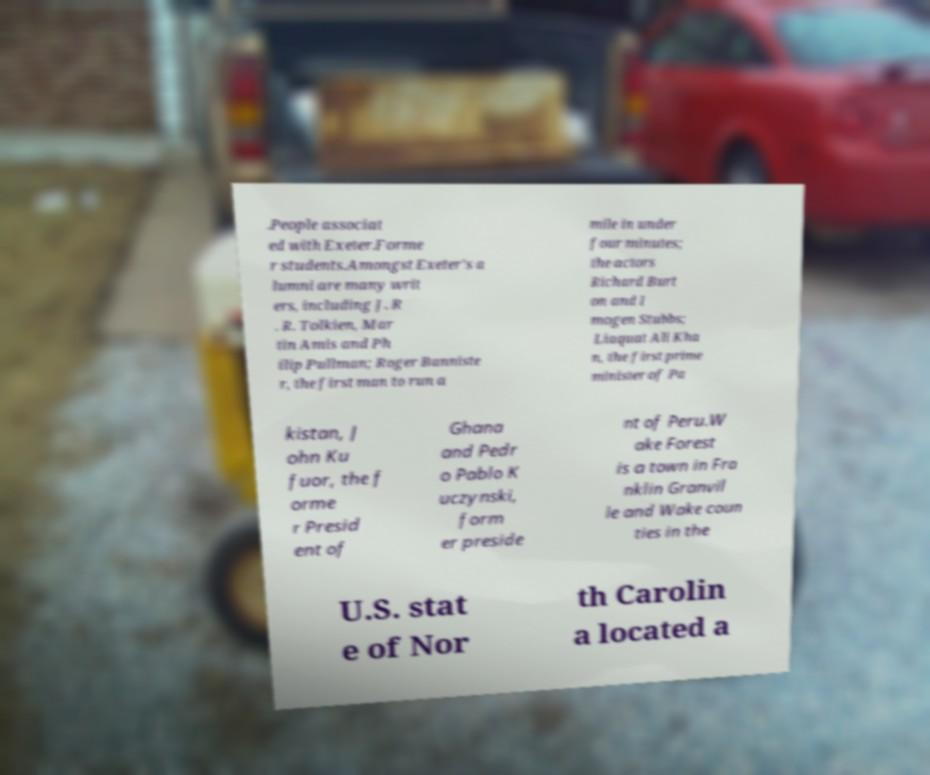Could you assist in decoding the text presented in this image and type it out clearly? .People associat ed with Exeter.Forme r students.Amongst Exeter's a lumni are many writ ers, including J. R . R. Tolkien, Mar tin Amis and Ph ilip Pullman; Roger Banniste r, the first man to run a mile in under four minutes; the actors Richard Burt on and I mogen Stubbs; Liaquat Ali Kha n, the first prime minister of Pa kistan, J ohn Ku fuor, the f orme r Presid ent of Ghana and Pedr o Pablo K uczynski, form er preside nt of Peru.W ake Forest is a town in Fra nklin Granvil le and Wake coun ties in the U.S. stat e of Nor th Carolin a located a 